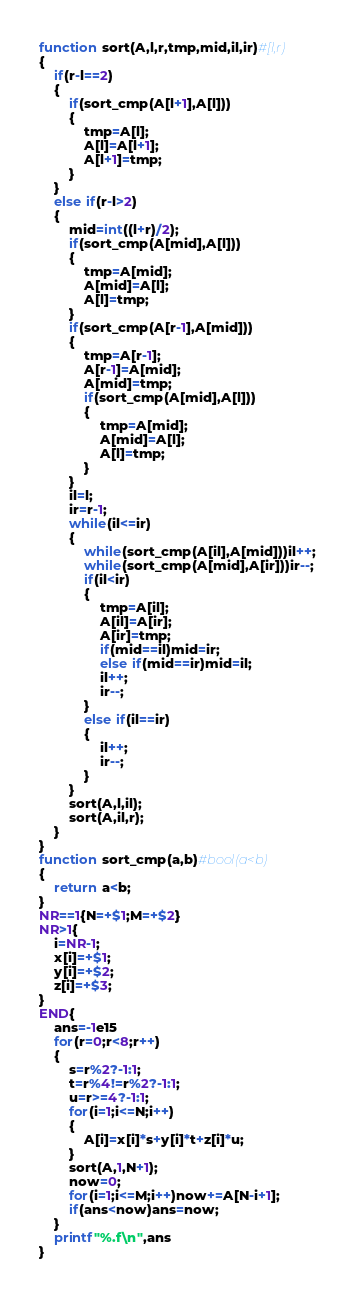<code> <loc_0><loc_0><loc_500><loc_500><_Awk_>function sort(A,l,r,tmp,mid,il,ir)#[l,r)
{
	if(r-l==2)
	{
		if(sort_cmp(A[l+1],A[l]))
		{
			tmp=A[l];
			A[l]=A[l+1];
			A[l+1]=tmp;
		}
	}
	else if(r-l>2)
	{
		mid=int((l+r)/2);
		if(sort_cmp(A[mid],A[l]))
		{
			tmp=A[mid];
			A[mid]=A[l];
			A[l]=tmp;
		}
		if(sort_cmp(A[r-1],A[mid]))
		{
			tmp=A[r-1];
			A[r-1]=A[mid];
			A[mid]=tmp;
			if(sort_cmp(A[mid],A[l]))
			{
				tmp=A[mid];
				A[mid]=A[l];
				A[l]=tmp;
			}
		}
		il=l;
		ir=r-1;
		while(il<=ir)
		{
			while(sort_cmp(A[il],A[mid]))il++;
			while(sort_cmp(A[mid],A[ir]))ir--;
			if(il<ir)
			{
				tmp=A[il];
				A[il]=A[ir];
				A[ir]=tmp;
				if(mid==il)mid=ir;
				else if(mid==ir)mid=il;
				il++;
				ir--;
			}
			else if(il==ir)
			{
				il++;
				ir--;
			}
		}
		sort(A,l,il);
		sort(A,il,r);
	}
}
function sort_cmp(a,b)#bool(a<b)
{
	return a<b;
}
NR==1{N=+$1;M=+$2}
NR>1{
	i=NR-1;
	x[i]=+$1;
	y[i]=+$2;
	z[i]=+$3;
}
END{
	ans=-1e15
	for(r=0;r<8;r++)
	{
		s=r%2?-1:1;
		t=r%4!=r%2?-1:1;
		u=r>=4?-1:1;
		for(i=1;i<=N;i++)
		{
			A[i]=x[i]*s+y[i]*t+z[i]*u;
		}
		sort(A,1,N+1);
		now=0;
		for(i=1;i<=M;i++)now+=A[N-i+1];
		if(ans<now)ans=now;
	}
	printf"%.f\n",ans
}
</code> 